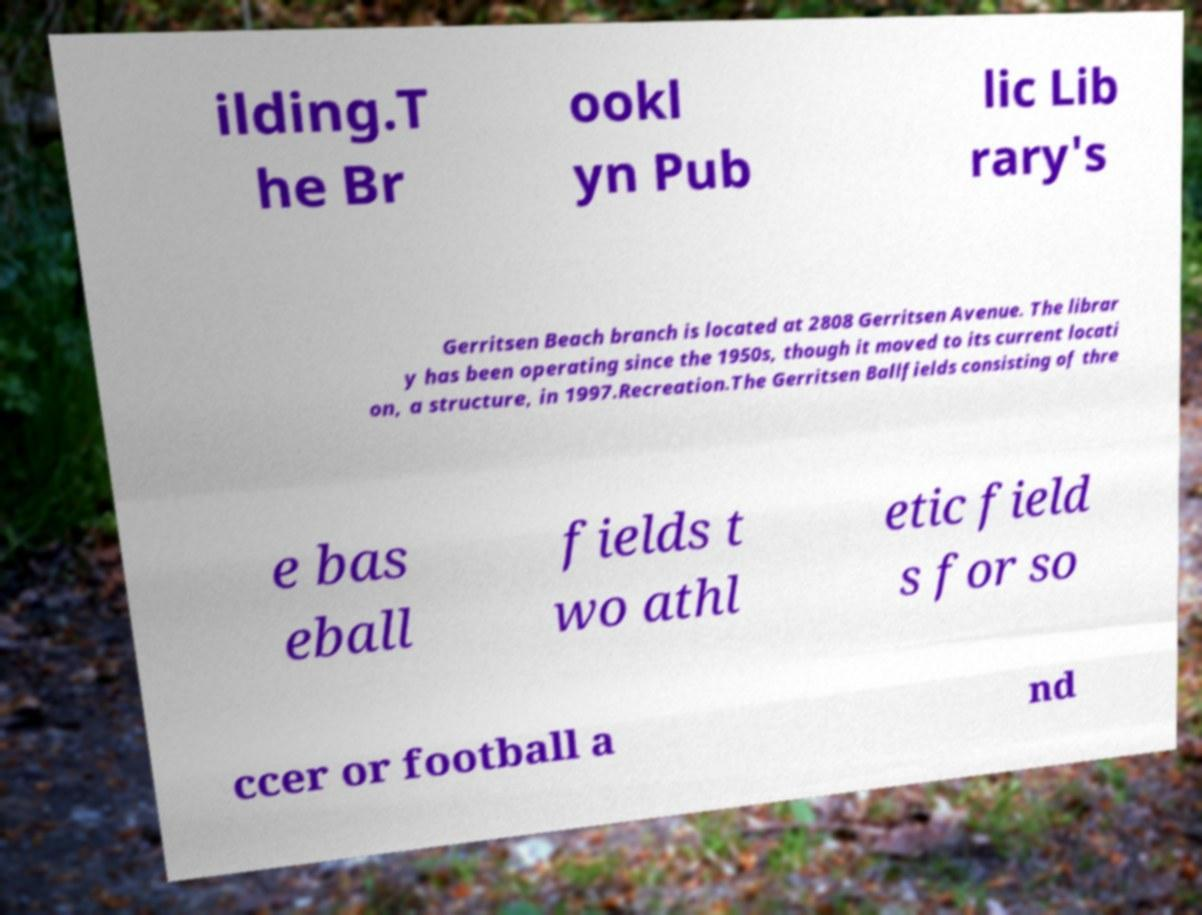Could you extract and type out the text from this image? ilding.T he Br ookl yn Pub lic Lib rary's Gerritsen Beach branch is located at 2808 Gerritsen Avenue. The librar y has been operating since the 1950s, though it moved to its current locati on, a structure, in 1997.Recreation.The Gerritsen Ballfields consisting of thre e bas eball fields t wo athl etic field s for so ccer or football a nd 